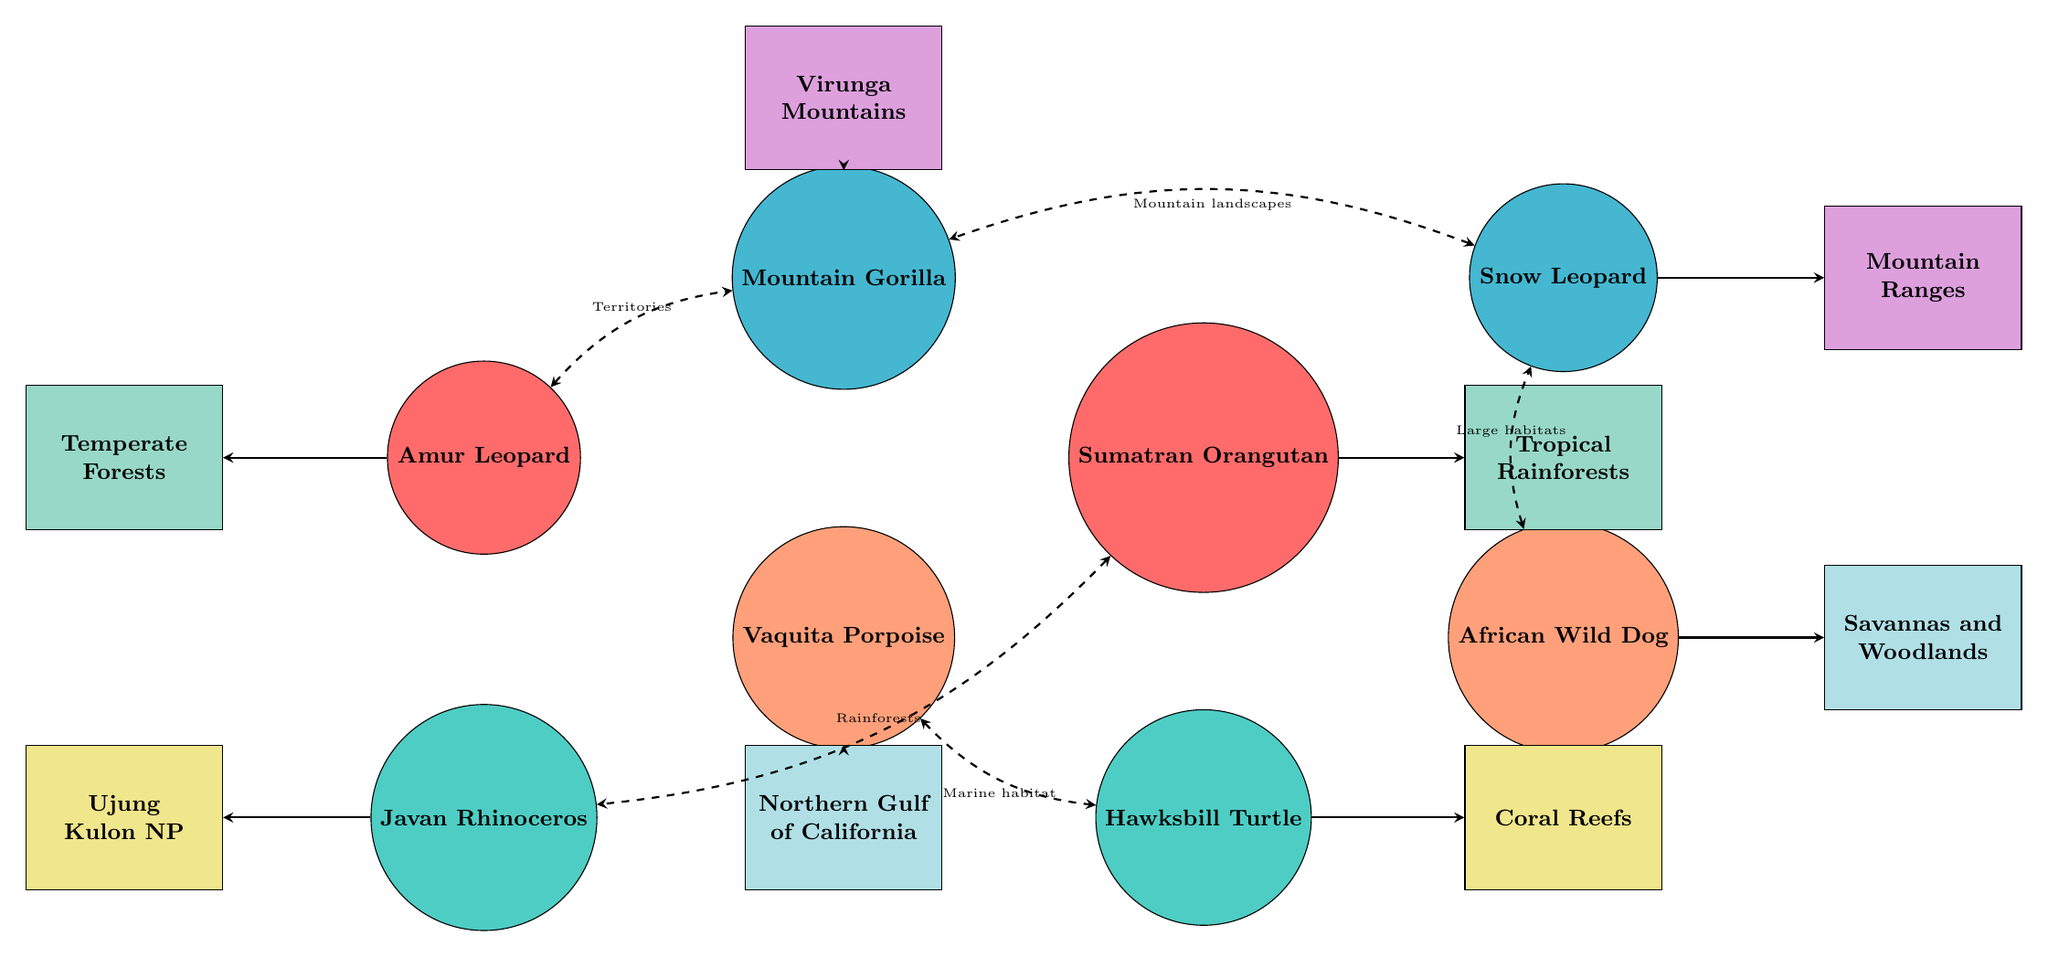What are the habitats connected to the Amur Leopard? The Amur Leopard is connected to the Temperate Forests of Russia and China in the diagram. Since the connections are directly sourced from the species nodes to their corresponding habitat nodes, I observe that the Amur Leopard is specifically linked with this habitat.
Answer: Temperate Forests of Russia and China How many species are represented in the diagram? There are a total of eight species identified in the diagram. This can be counted by simply listing each of the species nodes displayed in the diagram.
Answer: 8 What is the interdependency reason between the Vaquita Porpoise and the Hawksbill Turtle? The interdependency reason between the Vaquita Porpoise and the Hawksbill Turtle is due to both being affected by marine habitat degradation and relying on protected marine environments. This is stated on the dashed line between these two species.
Answer: Marine habitat Which species depends on large, connected habitats alongside the Snow Leopard? The African Wild Dog depends on large, connected habitats alongside the Snow Leopard. This relationship is indicated in the interdependency section of the diagram, displaying their mutual need for spacious habitats.
Answer: African Wild Dog What is the connection between the Sumatran Orangutan and the Javan Rhinoceros? The connection between the Sumatran Orangutan and the Javan Rhinoceros is that both depend on undisturbed tropical rainforests for food and shelter. This is indicated by the dashed line encapsulating their interdependency in the diagram.
Answer: Undisturbed tropical rainforests How many habitats are displayed in the diagram? The diagram displays eight distinct habitats. This can be confirmed by counting the habitat nodes presented in the visual representation.
Answer: 8 Which species is interdependent with the Mountain Gorilla, and why? The Amur Leopard is interdependent with the Mountain Gorilla because both rely on expansive territories and old-growth forests for hunting and shelter. The reasoning is specified in the interdependency connection illustrated in the diagram.
Answer: Amur Leopard What habitat is connected to the Arctic habitats? There are no Arctic habitats mentioned in the diagram. The provided data does not include any reference to Arctic habitats, and thus none can be connected as such.
Answer: None 